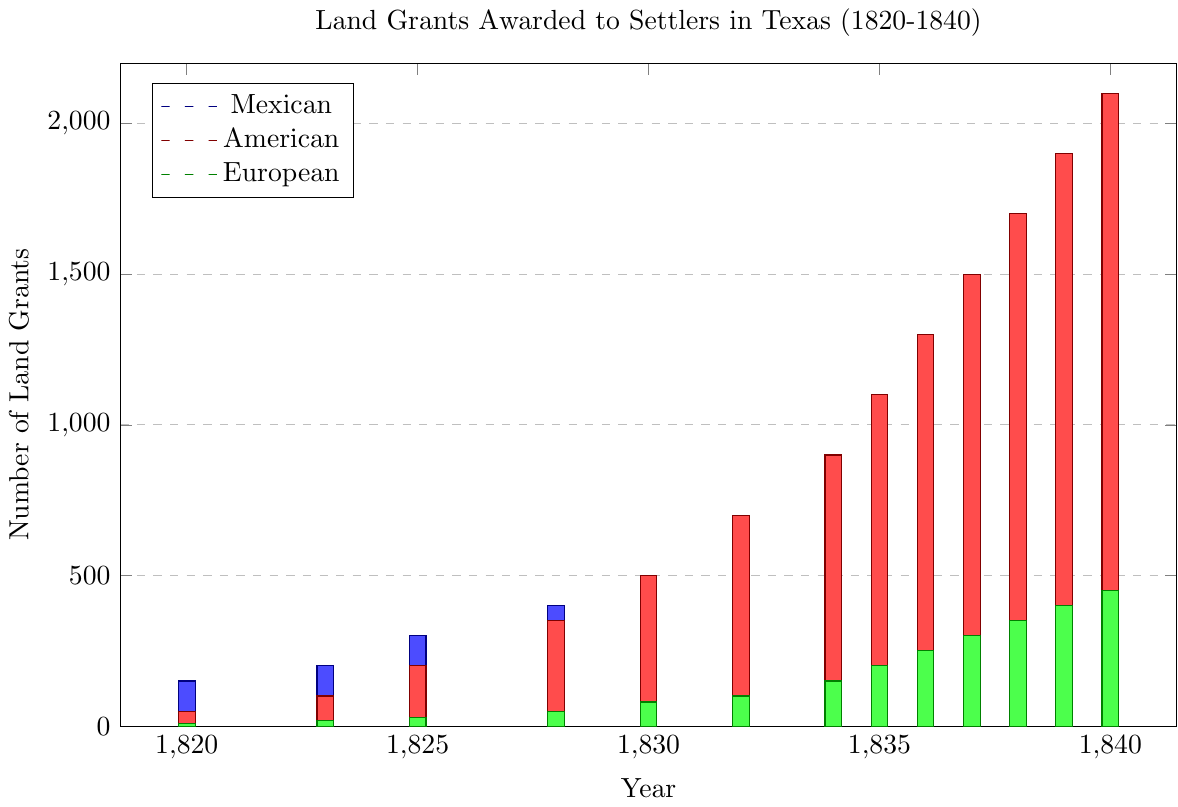Which year had the highest number of land grants awarded to American settlers? The height of the red bars representing American settlers indicates that the year with the highest number of land grants is when the red bar is the tallest. In this case, 1840 has the tallest red bar.
Answer: 1840 How many land grants were awarded to European settlers in total over the period 1820-1840? From the figure, each green bar represents the number of land grants to European settlers each year. Summing these up: 10 + 20 + 30 + 50 + 80 + 100 + 150 + 200 + 250 + 300 + 350 + 400 + 450 = 2390
Answer: 2390 During which year did Mexican settlers receive more land grants than American settlers? To find the years where the blue bars (Mexicans) are higher than the red bars (Americans), we look at each year: 1820, 1823, 1825, 1828.
Answer: 1820, 1823, 1825, 1828 What is the difference in the number of land grants awarded to Mexican settlers between the years 1834 and 1835? The blue bars for these years show Mexican settlers received 350 grants in 1834 and 300 in 1835. The difference is 350 - 300.
Answer: 50 Which nationality experienced the greatest increase in land grants from 1820 to 1840? By inspecting the bars for each nationality from 1820 to 1840, we calculate the increase for each:
Mexican: 10 - 150 = -140 
American: 2100 - 50 = 2050 
European: 450 - 10 = 440. Americans had the greatest increase.
Answer: American In which years were the total land grants awarded to all nationalities combined highest? To find the years with the highest total, we sum the heights of all bars for each year and compare:
1836: 200 + 1300 + 250 = 1750
1837: 100 + 1500 + 300 = 1900
1838: 50 + 1700 + 350 = 2100
1839: 25 + 1900 + 400 = 2325
1840: 10 + 2100 + 450 = 2560. 1840 has the highest total.
Answer: 1840 How did the number of land grants to Mexican settlers change from 1830 to 1836? Inspecting the blue bars for these years: 450 (1830) to 200 (1836). The change is a decrease of 450 - 200.
Answer: Decreased by 250 What is the ratio of land grants awarded to American settlers in 1820 compared to 1840? The number of land grants in 1820 was 50, and in 1840 it was 2100. The ratio is 50/2100 which simplifies to 1/42.
Answer: 1:42 Among all years, which year had the smallest number of land grants awarded to any group? Inspect the heights of the bars: the smallest blue bar is in 1840 with 10 grants awarded to Mexican settlers.
Answer: 1840 (Mexican settlers, 10 grants) 